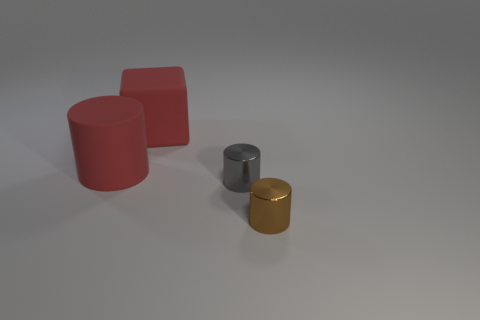Add 2 matte objects. How many objects exist? 6 Subtract all cubes. How many objects are left? 3 Subtract 1 red cylinders. How many objects are left? 3 Subtract all large green cubes. Subtract all small gray metallic things. How many objects are left? 3 Add 1 small gray things. How many small gray things are left? 2 Add 2 brown metal cylinders. How many brown metal cylinders exist? 3 